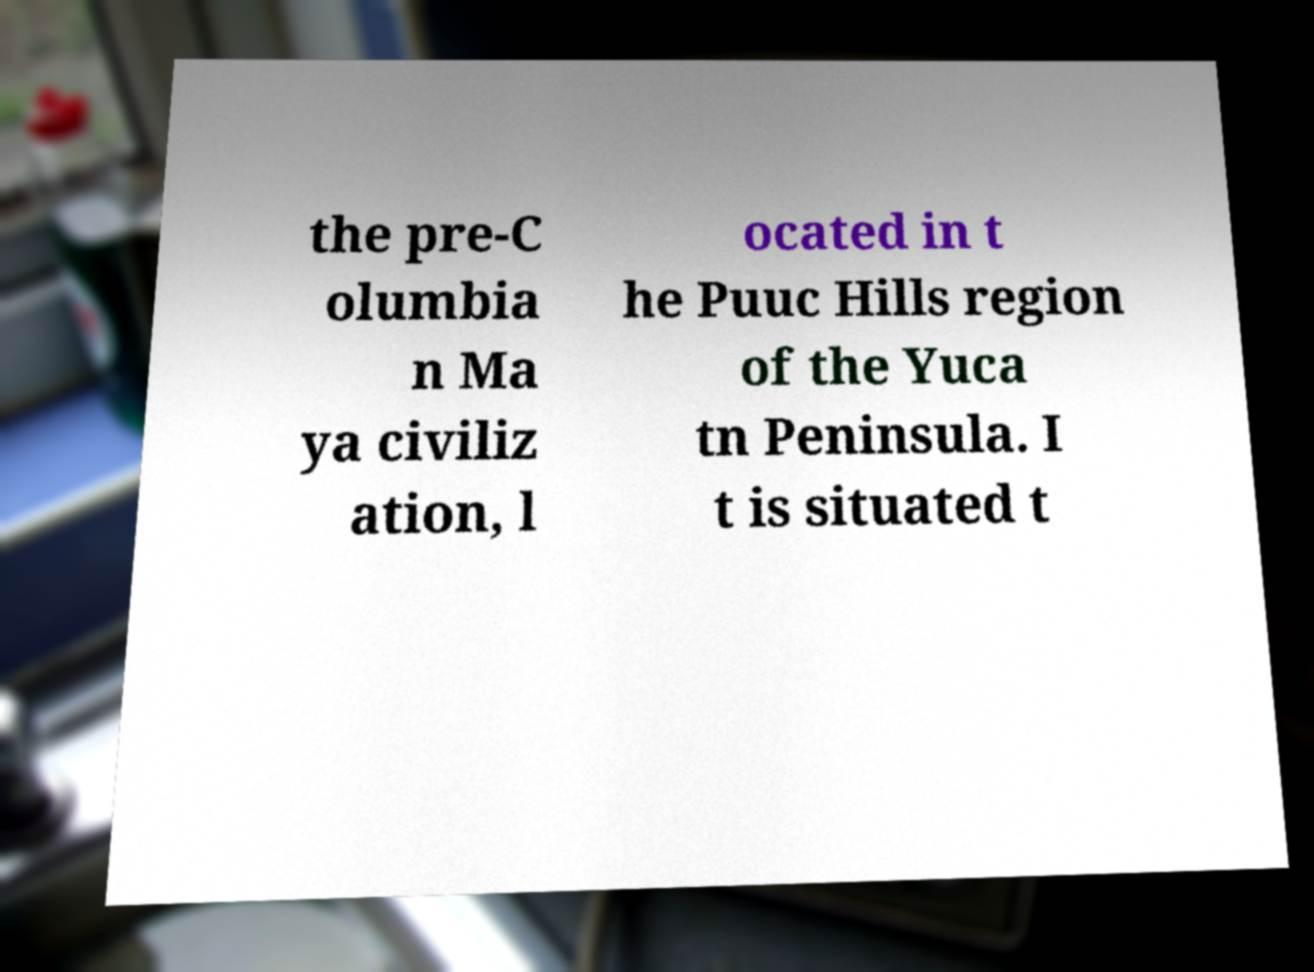Please identify and transcribe the text found in this image. the pre-C olumbia n Ma ya civiliz ation, l ocated in t he Puuc Hills region of the Yuca tn Peninsula. I t is situated t 